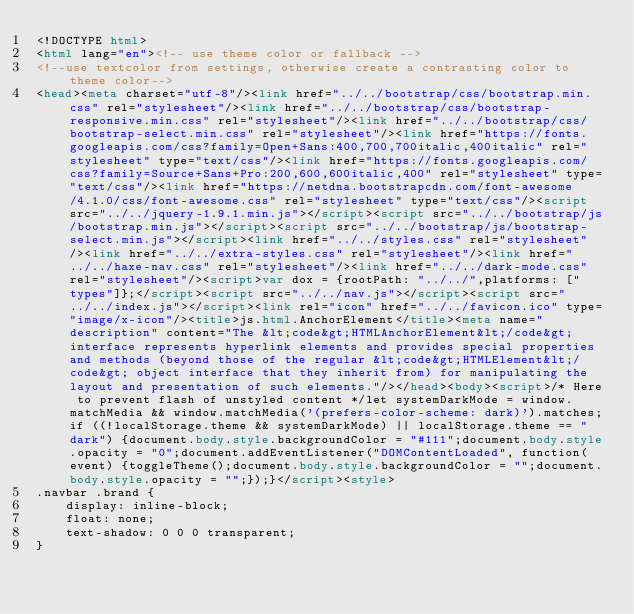<code> <loc_0><loc_0><loc_500><loc_500><_HTML_><!DOCTYPE html>
<html lang="en"><!-- use theme color or fallback -->
<!--use textcolor from settings, otherwise create a contrasting color to theme color-->
<head><meta charset="utf-8"/><link href="../../bootstrap/css/bootstrap.min.css" rel="stylesheet"/><link href="../../bootstrap/css/bootstrap-responsive.min.css" rel="stylesheet"/><link href="../../bootstrap/css/bootstrap-select.min.css" rel="stylesheet"/><link href="https://fonts.googleapis.com/css?family=Open+Sans:400,700,700italic,400italic" rel="stylesheet" type="text/css"/><link href="https://fonts.googleapis.com/css?family=Source+Sans+Pro:200,600,600italic,400" rel="stylesheet" type="text/css"/><link href="https://netdna.bootstrapcdn.com/font-awesome/4.1.0/css/font-awesome.css" rel="stylesheet" type="text/css"/><script src="../../jquery-1.9.1.min.js"></script><script src="../../bootstrap/js/bootstrap.min.js"></script><script src="../../bootstrap/js/bootstrap-select.min.js"></script><link href="../../styles.css" rel="stylesheet"/><link href="../../extra-styles.css" rel="stylesheet"/><link href="../../haxe-nav.css" rel="stylesheet"/><link href="../../dark-mode.css" rel="stylesheet"/><script>var dox = {rootPath: "../../",platforms: ["types"]};</script><script src="../../nav.js"></script><script src="../../index.js"></script><link rel="icon" href="../../favicon.ico" type="image/x-icon"/><title>js.html.AnchorElement</title><meta name="description" content="The &lt;code&gt;HTMLAnchorElement&lt;/code&gt; interface represents hyperlink elements and provides special properties and methods (beyond those of the regular &lt;code&gt;HTMLElement&lt;/code&gt; object interface that they inherit from) for manipulating the layout and presentation of such elements."/></head><body><script>/* Here to prevent flash of unstyled content */let systemDarkMode = window.matchMedia && window.matchMedia('(prefers-color-scheme: dark)').matches;if ((!localStorage.theme && systemDarkMode) || localStorage.theme == "dark") {document.body.style.backgroundColor = "#111";document.body.style.opacity = "0";document.addEventListener("DOMContentLoaded", function(event) {toggleTheme();document.body.style.backgroundColor = "";document.body.style.opacity = "";});}</script><style>
.navbar .brand {
	display: inline-block;
	float: none;
	text-shadow: 0 0 0 transparent;
}</code> 